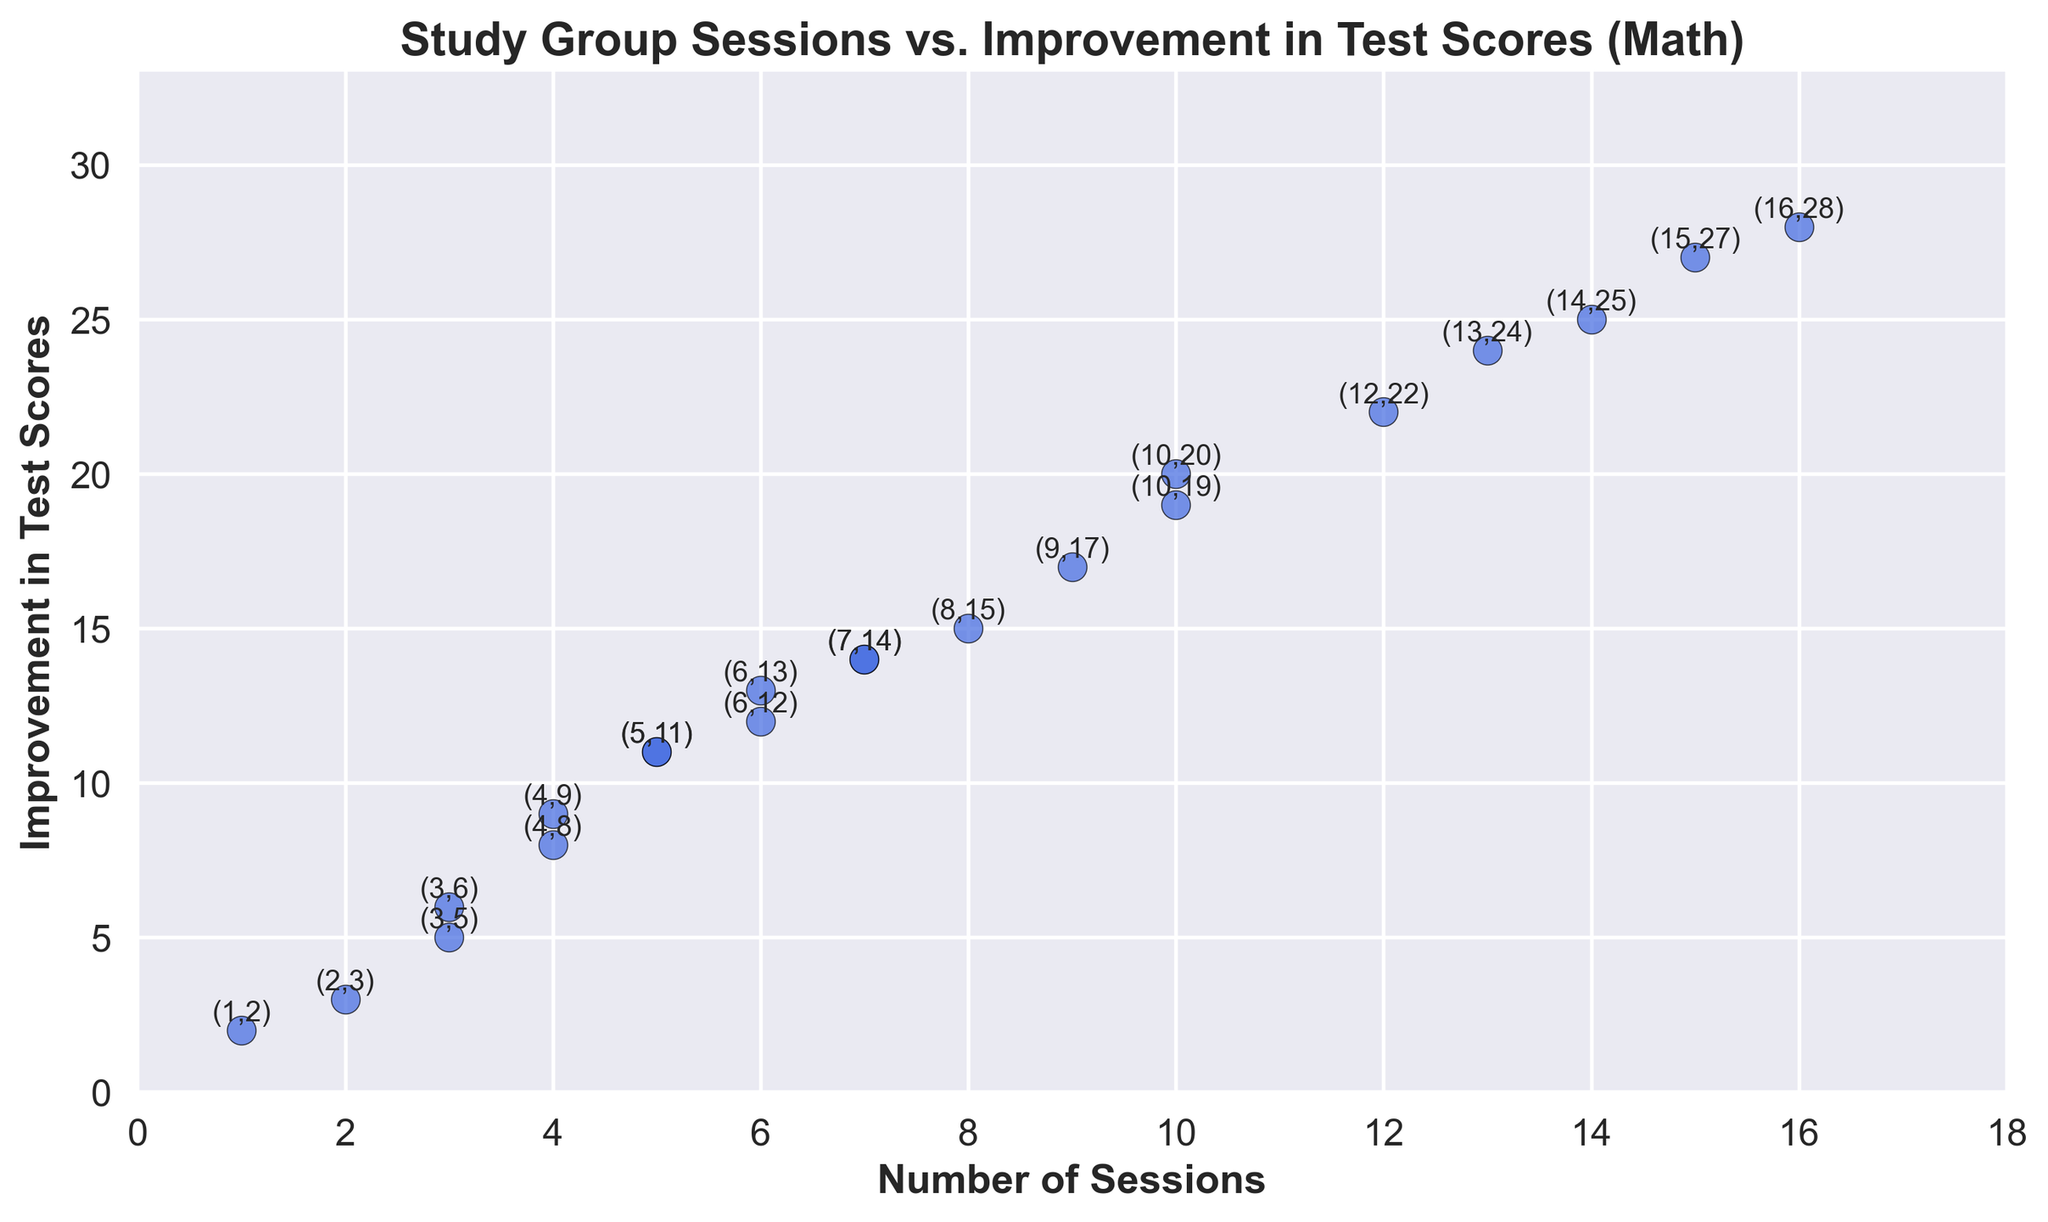What is the most significant improvement in test scores recorded at 10 sessions? Locate the data points where the number of sessions is 10. There are two such points with the test score improvements of 19 and 20. The larger value of these is 20.
Answer: 20 What is the difference in improvement in test scores between 4 and 8 sessions? Locate the data points for 4 and 8 sessions. At 4 sessions, the improvement is 9 and 8 scores, respectively. At 8 sessions, it is 15. The difference between the highest 4-session value and the 8-session value is 15 - 9 = 6.
Answer: 6 What is the total improvement in test scores for all the data points shown in the figure? Sum up all the improvement values: 2 + 5 + 3 + 9 + 11 + 6 + 12 + 14 + 15 + 13 + 11 + 14 + 17 + 8 + 19 + 22 + 20 + 25 + 27 + 24 + 28 = 315.
Answer: 315 How many sessions correspond to an improvement of exactly 14 points? Locate the data points where the improvement in test scores is 14. There are two points with session values of 7.
Answer: 2 Is there a session count that corresponds to more than one improvement in test scores? Check each number of sessions to see if there are multiple associated improvements in test scores. The numbers 4, 5, 6, 7, 10, and 13 each appear more than once.
Answer: Yes What is the average improvement in test scores for sessions from 5 to 10? Identify the data points for sessions 5, 6, 7, 8, 9, and 10. Their improvement values are 11, 11, 12, 13, 14, 15, 17, 19, and 20. Sum these up to get 132, and divide by 9 (the number of data points) to get an average improvement of 14.67.
Answer: 14.67 Which sessions show an improvement exactly 2 points higher than a previous session? Look at all consecutive differences in improvements and identify those that show an improvement increase of 2 points. The pairs (1, 2), (5, 7), (10, 12), (12, 14), and (14, 16) meet this criterion.
Answer: 5 and 7 What is the median improvement in test scores for all the sessions? List the improvements and find the median value, which is the middle value when all the data points are arranged in ascending order. The improvements are 2, 3, 5, 6, 8, 9, 11, 11, 12, 13, 14, 14, 15, 17, 19, 20, 22, 24, 25, 27, 28. The median value is the 11th value in this list, which is 14.
Answer: 14 